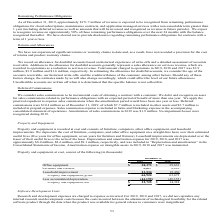According to Manhattan Associates's financial document, How is the leasehold improvement depreciated? over the lesser of their useful lives or the term of the lease. The document states: "fixtures). Leasehold improvements are depreciated over the lesser of their useful lives or the term of the lease. Depreciation and amortization expens..." Also, What consists of property and equipment cost? furniture, computers, other office equipment, and leasehold improvements. The document states: "and equipment is recorded at cost and consists of furniture, computers, other office equipment, and leasehold improvements. We depreciate the cost of ..." Also, What is the property and equipment, net in 2019? According to the financial document, 22,725 (in thousands). The relevant text states: "Property and equipment, net $ 22,725 $ 14,318..." Also, can you calculate: What is the change in depreciation and amortization cost between 2019 and 2018? Based on the calculation: $8.6-8.0, the result is 0.6 (in millions). This is based on the information: ", 2018, and 2017 was approximately $8.0 million, $8.6 million, and $9.1 million, respectively, and was included in “Depreciation and amortization” in the pense for 2019, 2018, and 2017 was approximate..." The key data points involved are: 8.0, 8.6. Also, can you calculate: What is the change in office equipment cost in 2019 and 2018? Based on the calculation: $39,633-38,373, the result is 1260 (in thousands). This is based on the information: "Office equipment $ 38,373  $ 39,633 Office equipment $ 38,373  $ 39,633..." The key data points involved are: 38,373, 39,633. Also, can you calculate: What is the change in property and equipment, net cost in 2019 and 2018? Based on the calculation: $22,725-$14,318, the result is 8407 (in thousands). This is based on the information: "Property and equipment, net $ 22,725 $ 14,318 Property and equipment, net $ 22,725 $ 14,318..." The key data points involved are: 14,318, 22,725. 